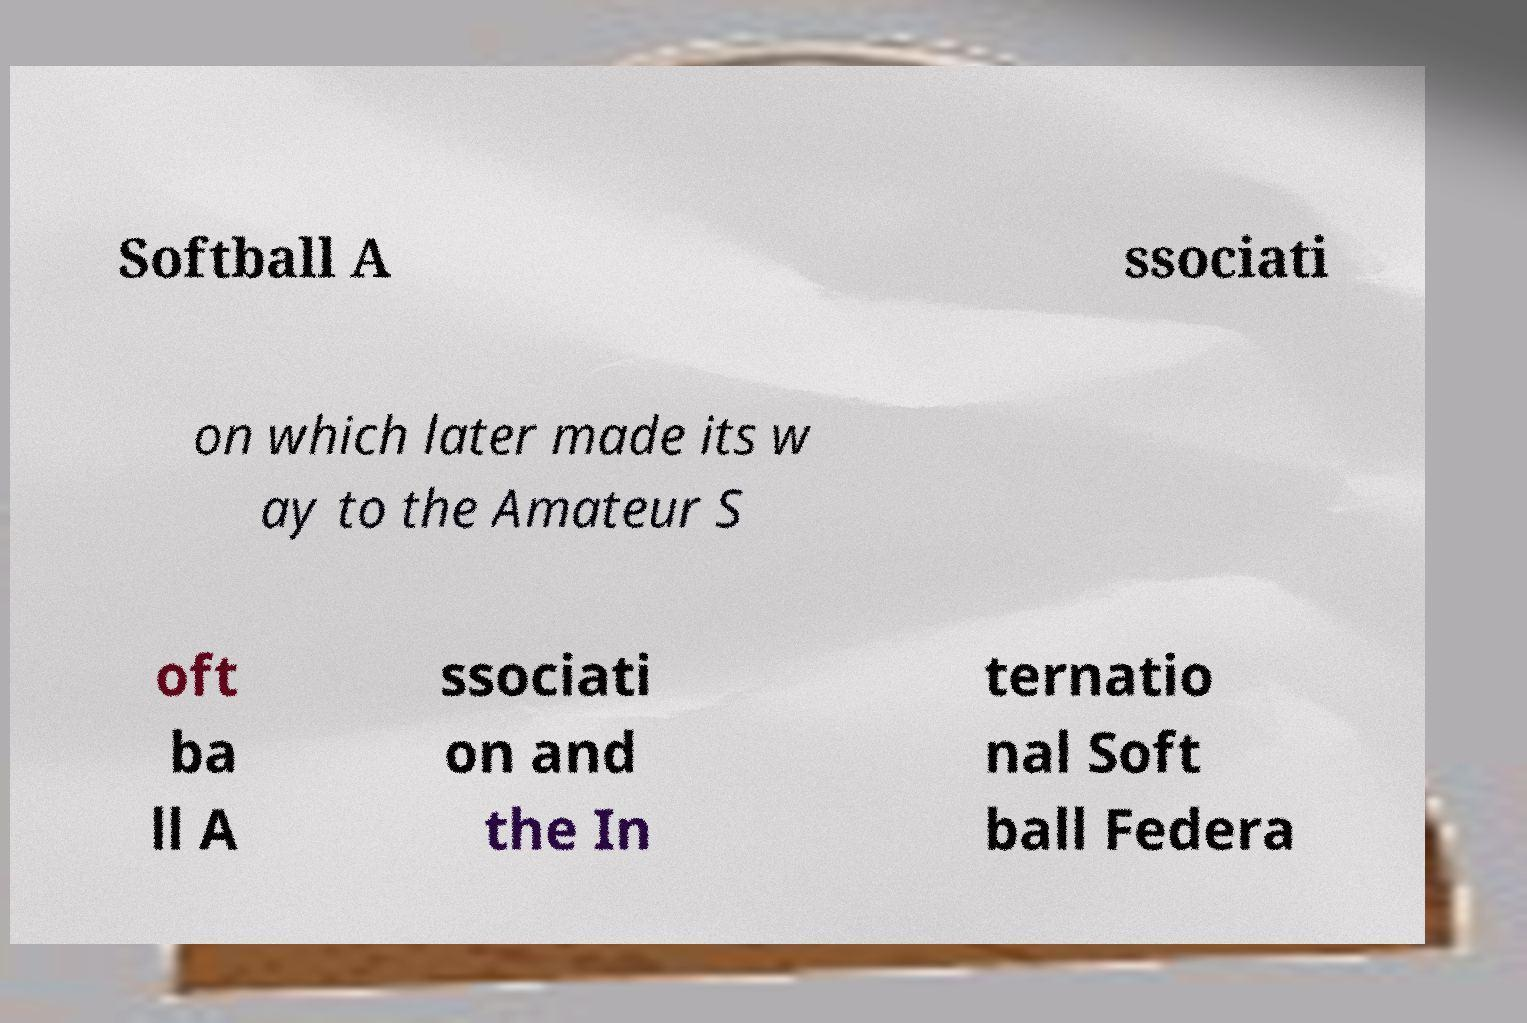Please read and relay the text visible in this image. What does it say? Softball A ssociati on which later made its w ay to the Amateur S oft ba ll A ssociati on and the In ternatio nal Soft ball Federa 